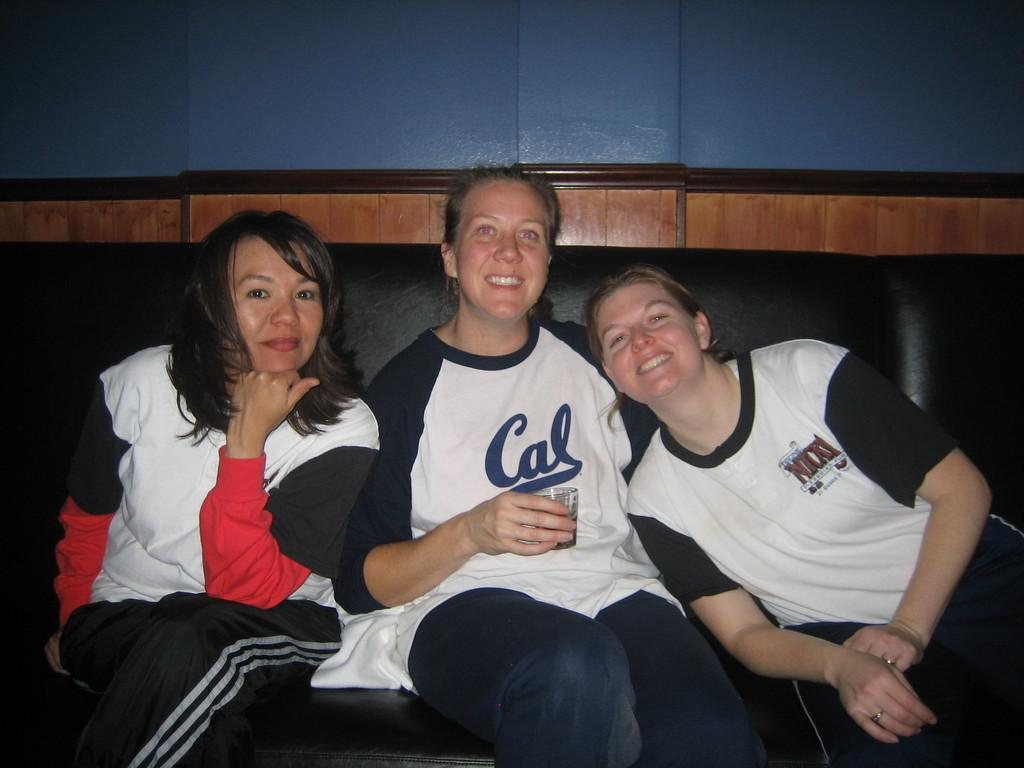What is present in the background of the image? There is a wall in the image. How many people are visible in the image? There are three people in the image. What are the people wearing? The people are wearing white t-shirts. Where are the people sitting? The people are sitting on a sofa. Can you see a duck holding a brick in the image? There is no duck or brick present in the image. How are the people gripping the sofa in the image? The people are sitting on the sofa, not gripping it, so this question cannot be answered based on the image. 